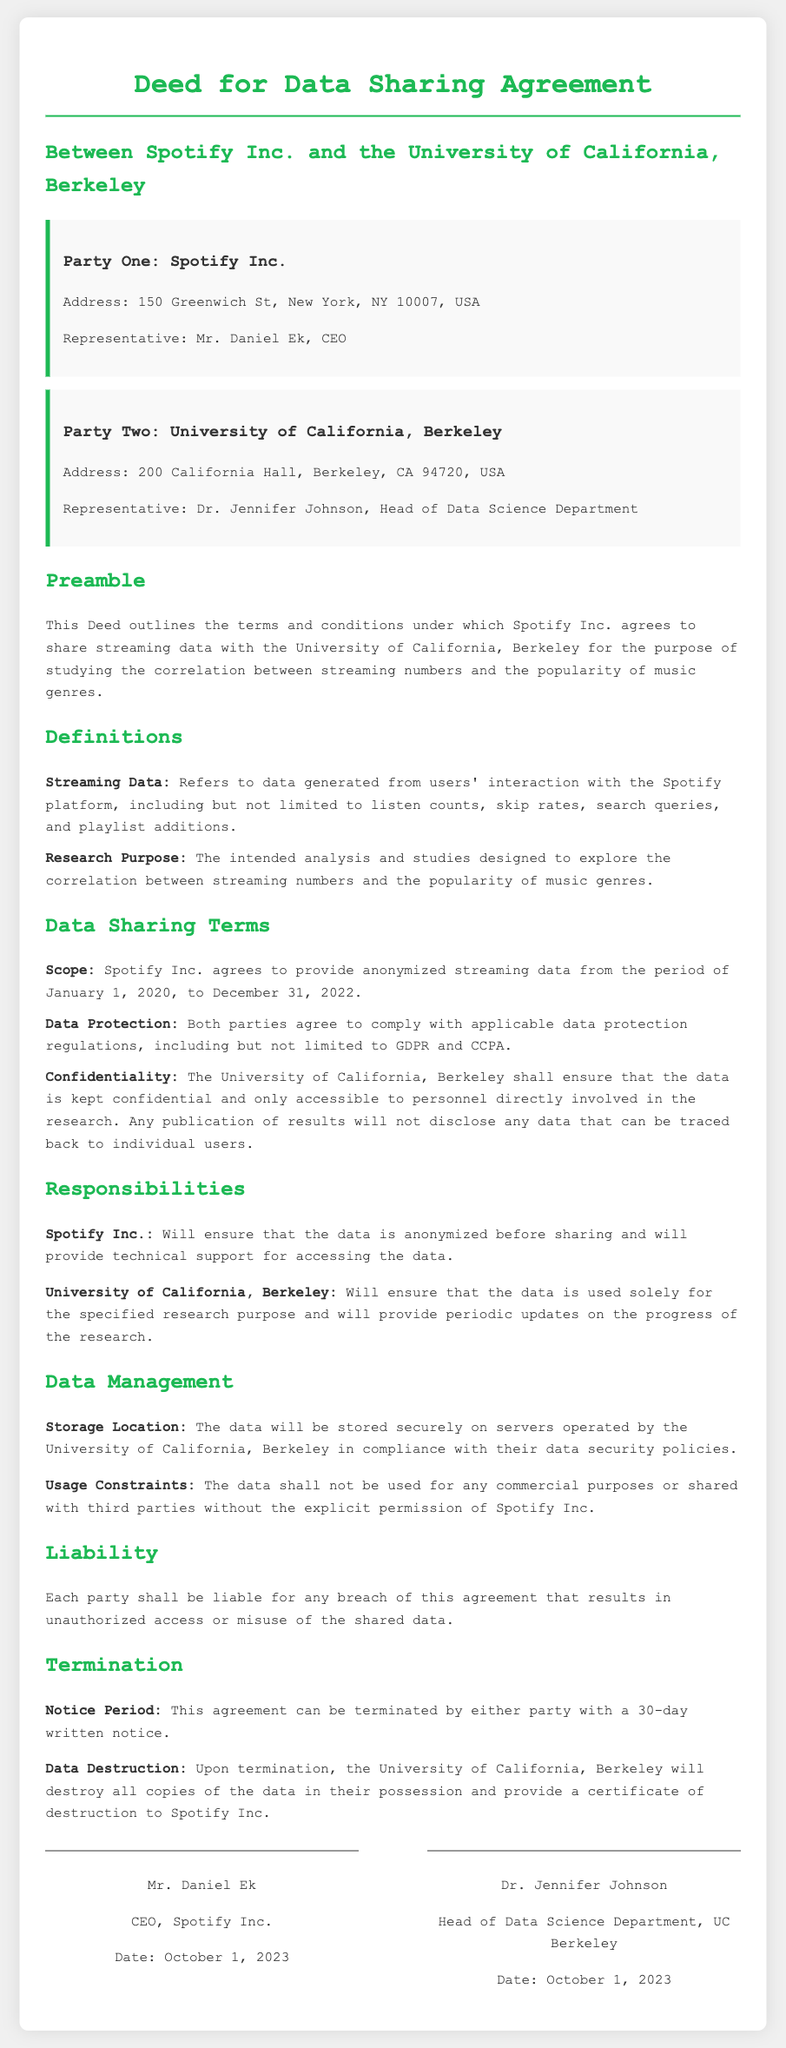What is the name of Party One? Party One in the document is Spotify Inc., which is mentioned in the title and defined initially.
Answer: Spotify Inc Who is the representative of Party Two? The representative of Party Two is stated in the section about the University of California, Berkeley.
Answer: Dr. Jennifer Johnson What is the address of Spotify Inc.? The address of Spotify Inc. is provided in the details of Party One.
Answer: 150 Greenwich St, New York, NY 10007, USA What is the scope of the data sharing? The scope of the data sharing includes details about the period and type of data involved in the agreement.
Answer: Anonymized streaming data from January 1, 2020, to December 31, 2022 What is the notice period for termination? The document specifies the notice period that is required for terminating the agreement.
Answer: 30-day written notice What are the data protection regulations mentioned? The document lists specific regulations both parties must comply with regarding data protection.
Answer: GDPR and CCPA What will the University of California, Berkeley ensure regarding data confidentiality? This part of the document discusses the responsibilities of the University regarding the confidentiality of the data shared.
Answer: The data is kept confidential and only accessible to personnel directly involved in the research What will happen to the data upon termination of the agreement? The document outlines the procedures required to handle the data at the end of the agreement.
Answer: Destroy all copies of the data in their possession What does Spotify Inc. agree to provide along with the data? The responsibilities section mentions what additional support Spotify Inc. will offer.
Answer: Technical support for accessing the data 